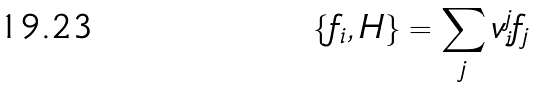<formula> <loc_0><loc_0><loc_500><loc_500>\{ f _ { i } , H \} = \sum _ { j } v _ { i } ^ { j } f _ { j }</formula> 